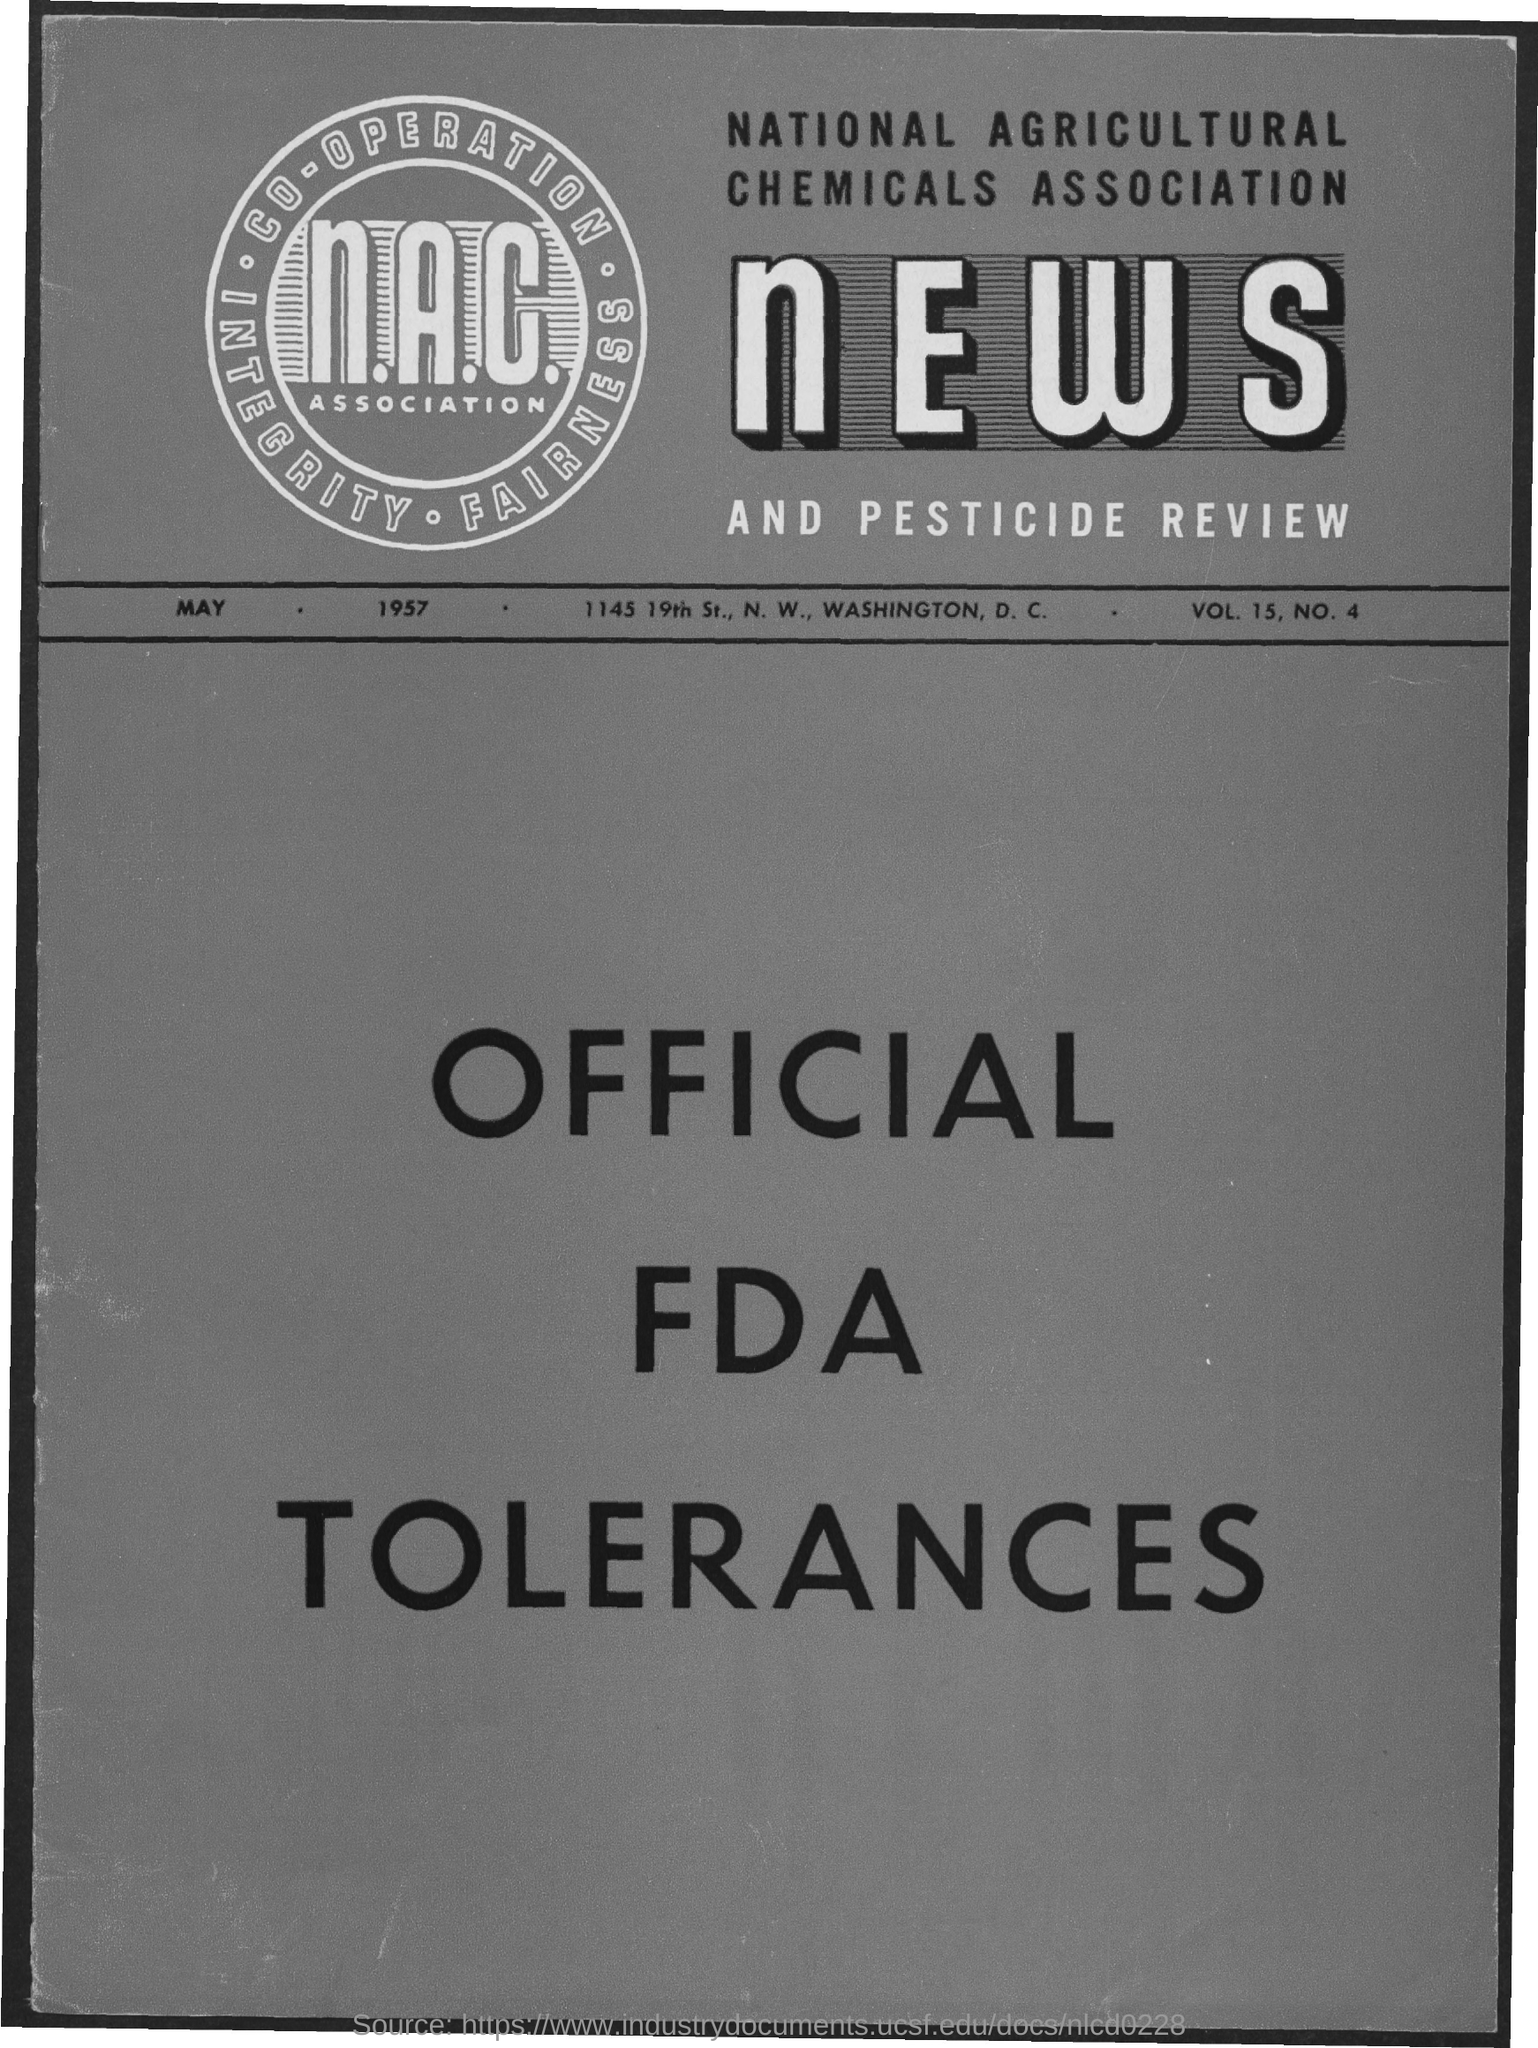What is the first title in the document?
Offer a very short reply. National Agricultural Chemicals Association. 